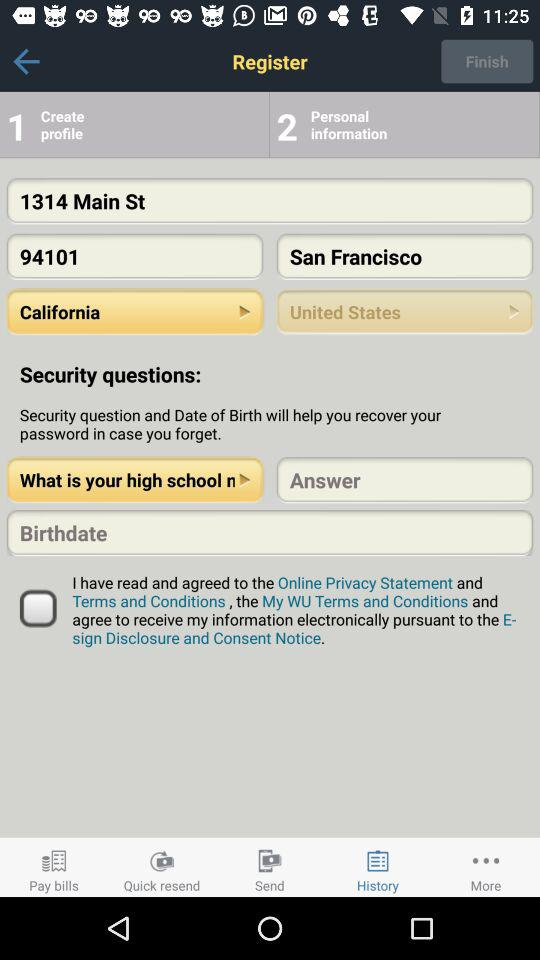What is the selected country? The selected country is the United States. 